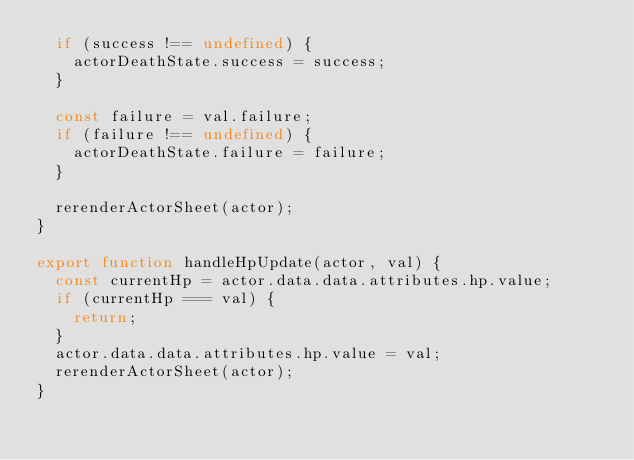<code> <loc_0><loc_0><loc_500><loc_500><_JavaScript_>  if (success !== undefined) {
    actorDeathState.success = success;
  }

  const failure = val.failure;
  if (failure !== undefined) {
    actorDeathState.failure = failure;
  }

  rerenderActorSheet(actor);
}

export function handleHpUpdate(actor, val) {
  const currentHp = actor.data.data.attributes.hp.value;
  if (currentHp === val) {
    return;
  }
  actor.data.data.attributes.hp.value = val;
  rerenderActorSheet(actor);
}
</code> 